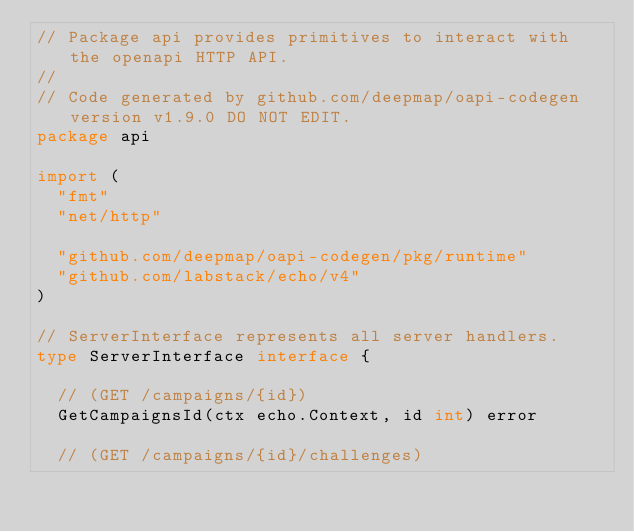Convert code to text. <code><loc_0><loc_0><loc_500><loc_500><_Go_>// Package api provides primitives to interact with the openapi HTTP API.
//
// Code generated by github.com/deepmap/oapi-codegen version v1.9.0 DO NOT EDIT.
package api

import (
	"fmt"
	"net/http"

	"github.com/deepmap/oapi-codegen/pkg/runtime"
	"github.com/labstack/echo/v4"
)

// ServerInterface represents all server handlers.
type ServerInterface interface {

	// (GET /campaigns/{id})
	GetCampaignsId(ctx echo.Context, id int) error

	// (GET /campaigns/{id}/challenges)</code> 